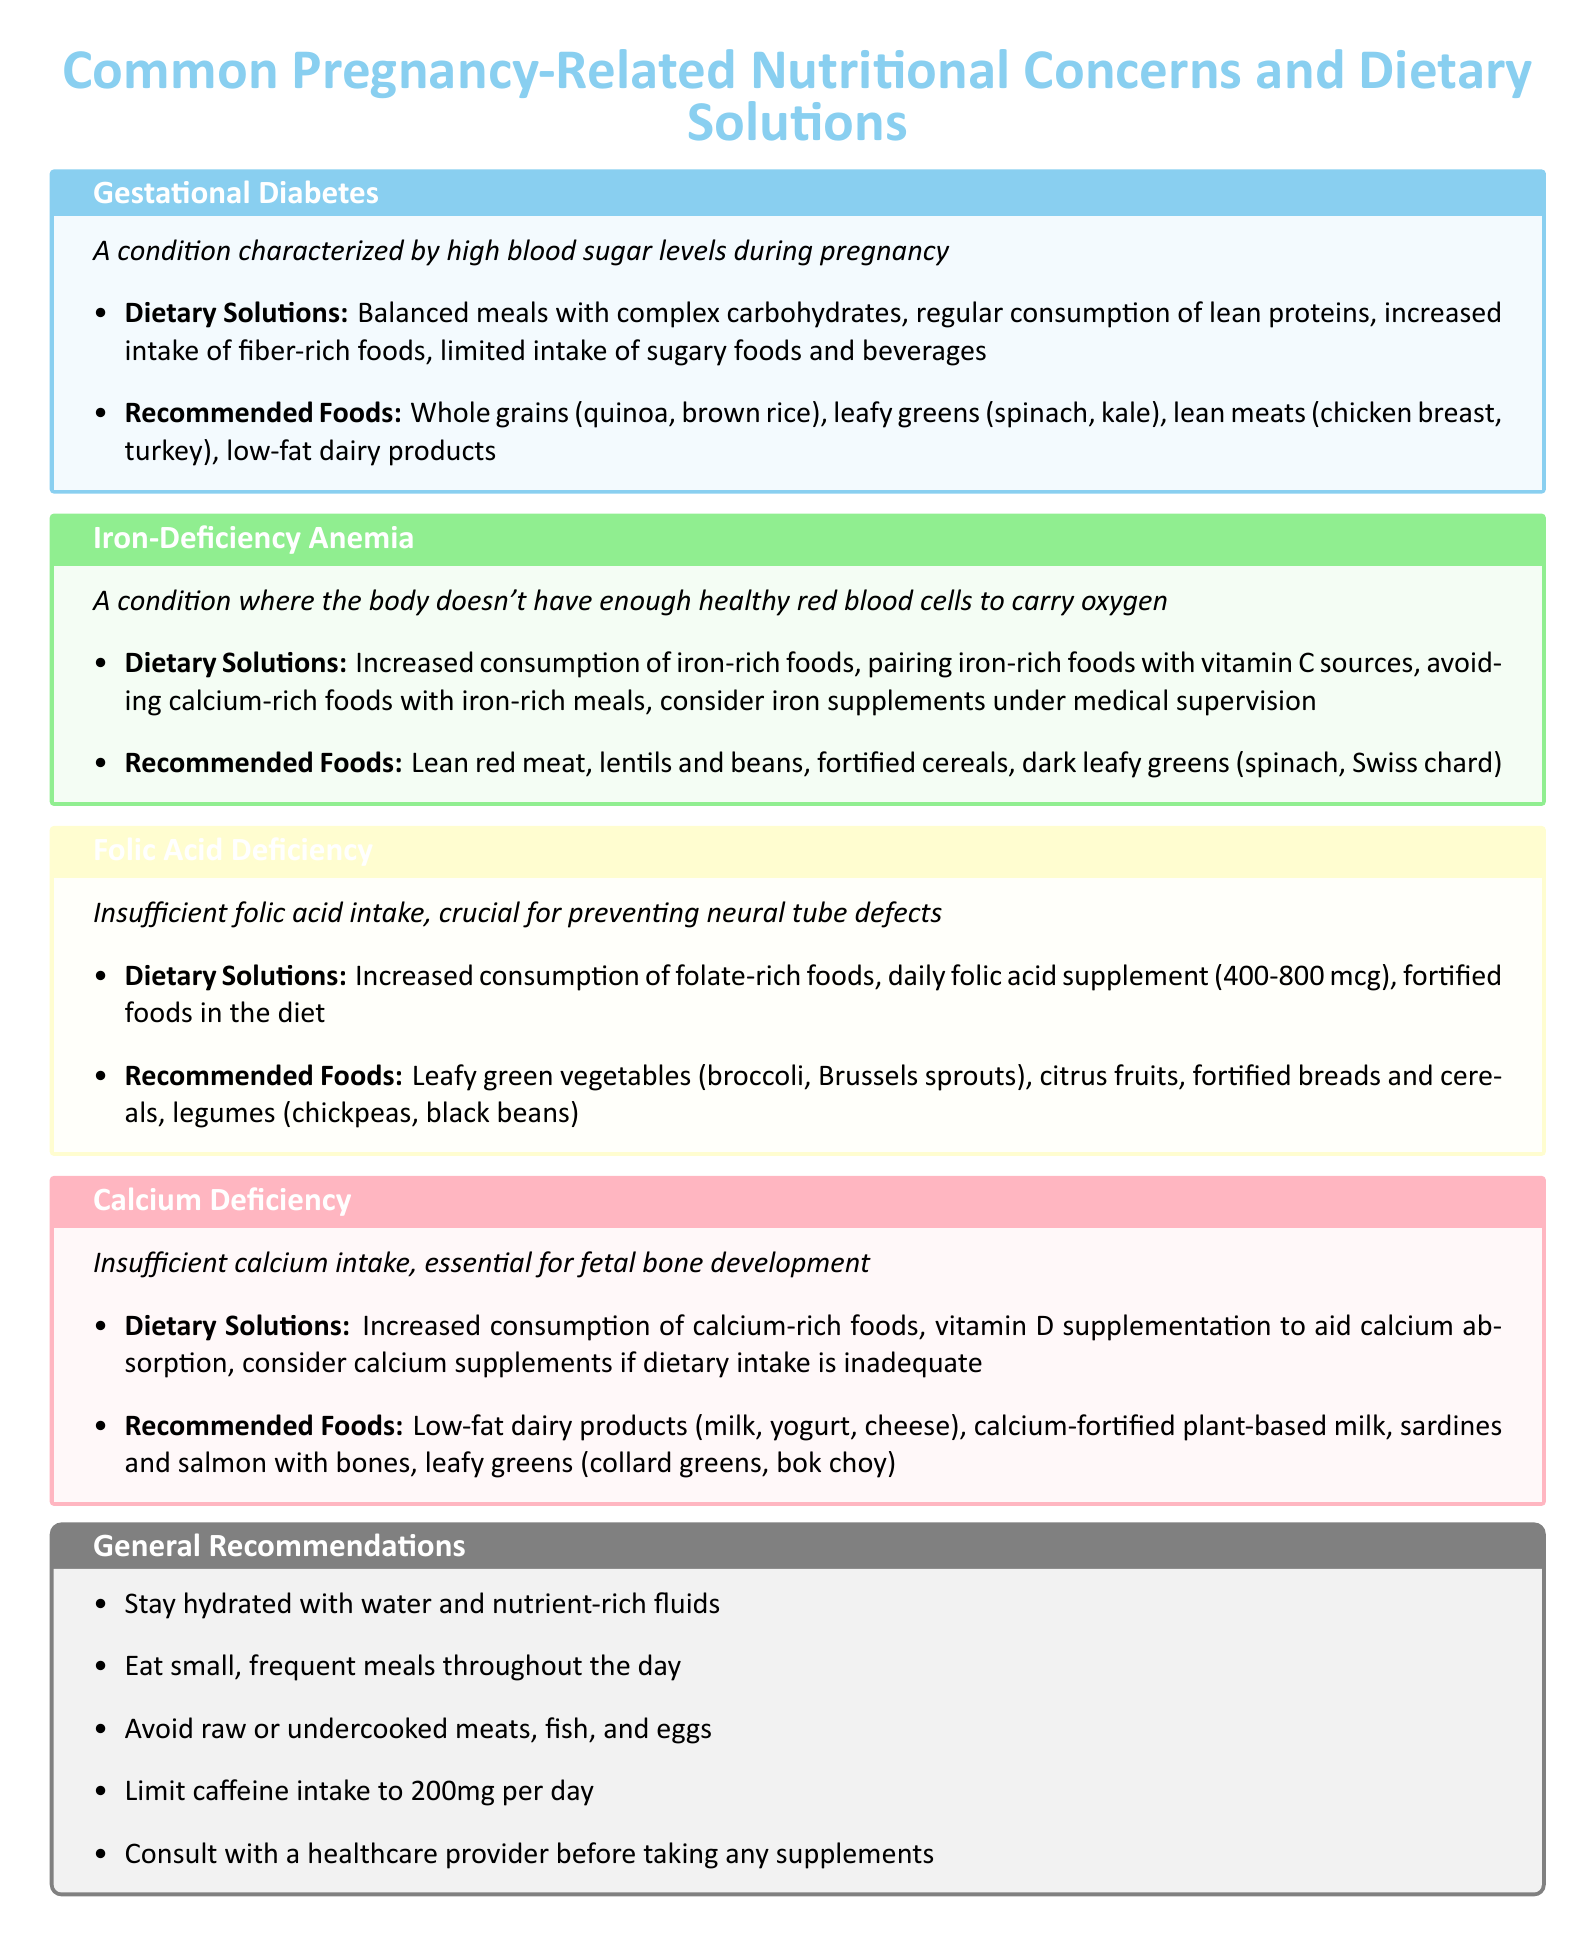What is gestational diabetes? Gestational diabetes is characterized by high blood sugar levels during pregnancy.
Answer: High blood sugar levels during pregnancy What foods are recommended for iron-deficiency anemia? The document lists several foods recommended for iron-deficiency anemia, which include lean red meat, lentils, and dark leafy greens.
Answer: Lean red meat, lentils and beans, dark leafy greens What is the dietary solution for calcium deficiency? For calcium deficiency, the document suggests increased consumption of calcium-rich foods and vitamin D supplementation.
Answer: Increased consumption of calcium-rich foods How much folic acid supplement is recommended daily? The document recommends a daily folic acid supplement of 400-800 mcg.
Answer: 400-800 mcg What is a general recommendation for hydration during pregnancy? The document advises staying hydrated with water and nutrient-rich fluids.
Answer: Stay hydrated with water and nutrient-rich fluids What should pregnant women limit in their diet? The document states that pregnant women should limit caffeine intake to 200mg per day.
Answer: Caffeine intake to 200mg per day What is a crucial function of folic acid during pregnancy? The document highlights that folic acid is crucial for preventing neural tube defects.
Answer: Preventing neural tube defects Which leafy green is recommended for calcium intake? The document specifically mentions collard greens and bok choy as recommended leafy greens for calcium.
Answer: Collard greens, bok choy 